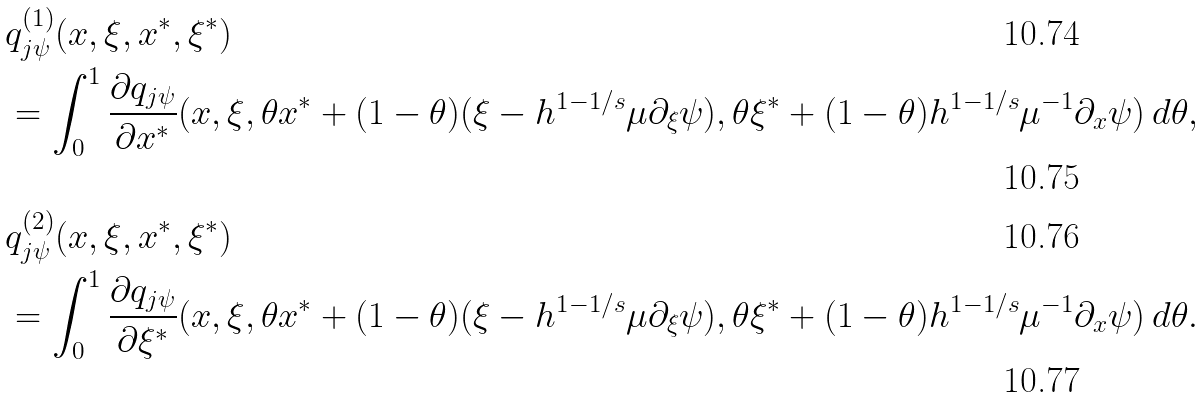Convert formula to latex. <formula><loc_0><loc_0><loc_500><loc_500>& q _ { j \psi } ^ { ( 1 ) } ( x , \xi , x ^ { * } , \xi ^ { * } ) \\ & = \int _ { 0 } ^ { 1 } \frac { \partial q _ { j \psi } } { \partial x ^ { * } } ( x , \xi , \theta x ^ { * } + ( 1 - \theta ) ( \xi - h ^ { 1 - 1 / s } \mu \partial _ { \xi } \psi ) , \theta \xi ^ { * } + ( 1 - \theta ) h ^ { 1 - 1 / s } \mu ^ { - 1 } \partial _ { x } \psi ) \, d \theta , \\ & q _ { j \psi } ^ { ( 2 ) } ( x , \xi , x ^ { * } , \xi ^ { * } ) \\ & = \int _ { 0 } ^ { 1 } \frac { \partial q _ { j \psi } } { \partial \xi ^ { * } } ( x , \xi , \theta x ^ { * } + ( 1 - \theta ) ( \xi - h ^ { 1 - 1 / s } \mu \partial _ { \xi } \psi ) , \theta \xi ^ { * } + ( 1 - \theta ) h ^ { 1 - 1 / s } \mu ^ { - 1 } \partial _ { x } \psi ) \, d \theta .</formula> 